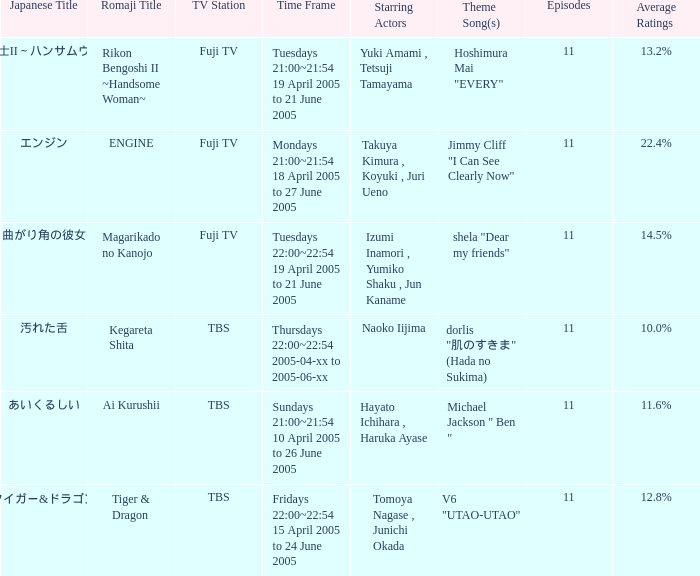Which japanese title has an 11.6% average rating? あいくるしい. 